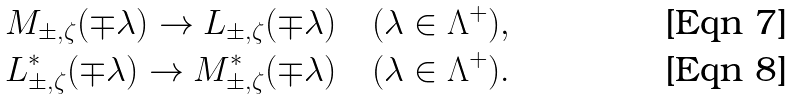<formula> <loc_0><loc_0><loc_500><loc_500>M _ { \pm , \zeta } ( \mp \lambda ) \to L _ { \pm , \zeta } ( \mp \lambda ) \quad ( \lambda \in \Lambda ^ { + } ) , \\ L ^ { * } _ { \pm , \zeta } ( \mp \lambda ) \to M ^ { * } _ { \pm , \zeta } ( \mp \lambda ) \quad ( \lambda \in \Lambda ^ { + } ) .</formula> 